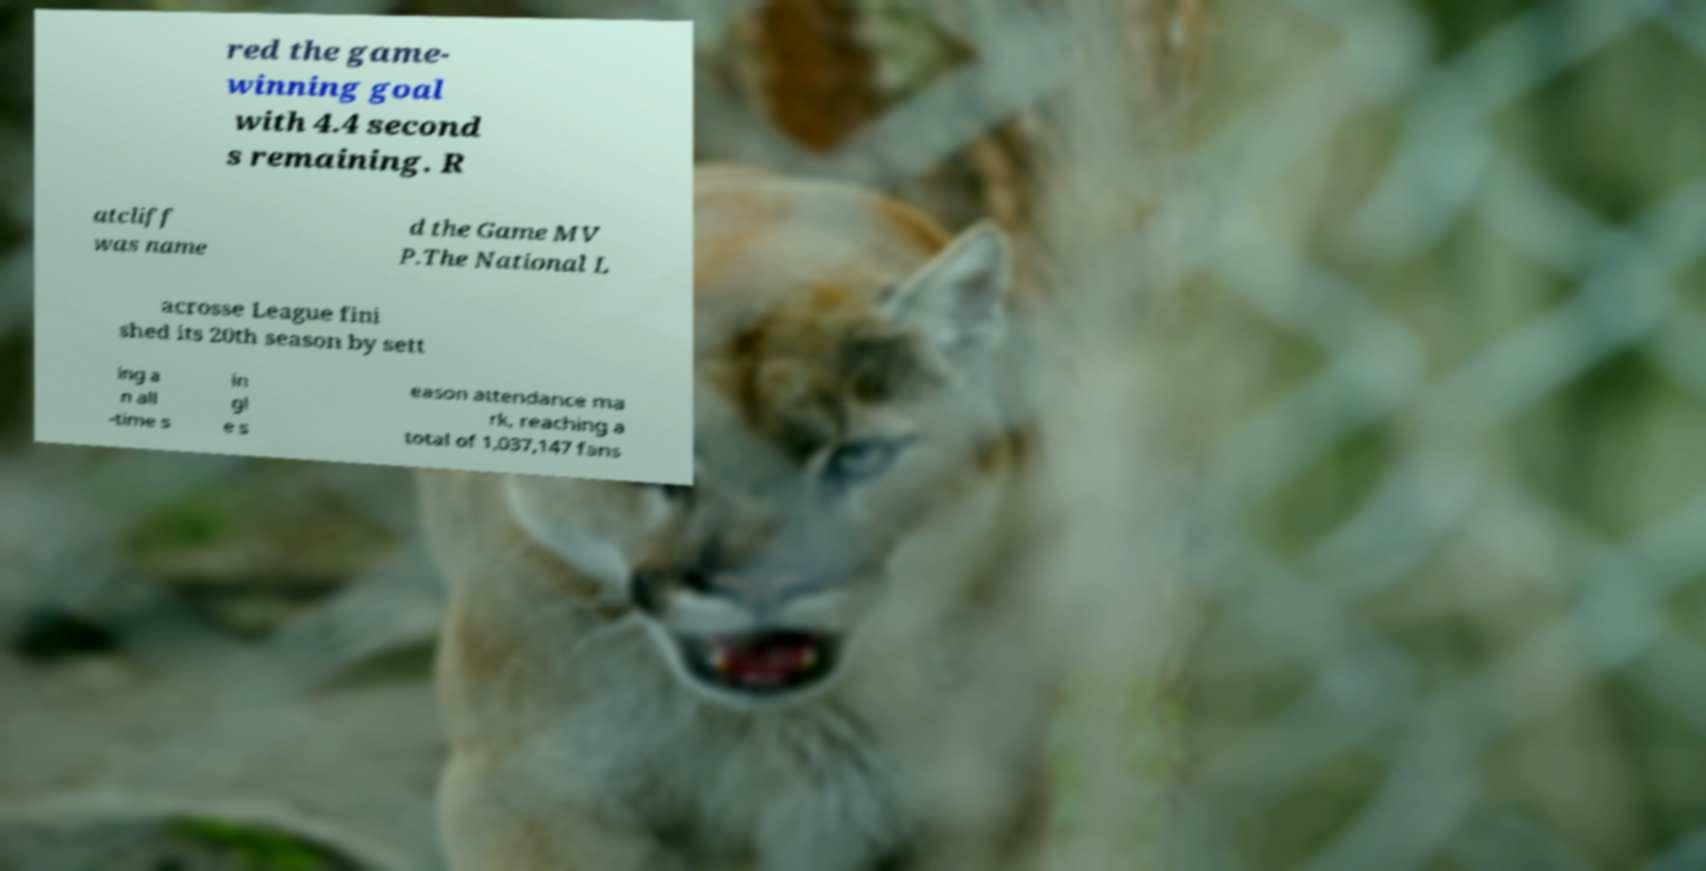Can you read and provide the text displayed in the image?This photo seems to have some interesting text. Can you extract and type it out for me? red the game- winning goal with 4.4 second s remaining. R atcliff was name d the Game MV P.The National L acrosse League fini shed its 20th season by sett ing a n all -time s in gl e s eason attendance ma rk, reaching a total of 1,037,147 fans 